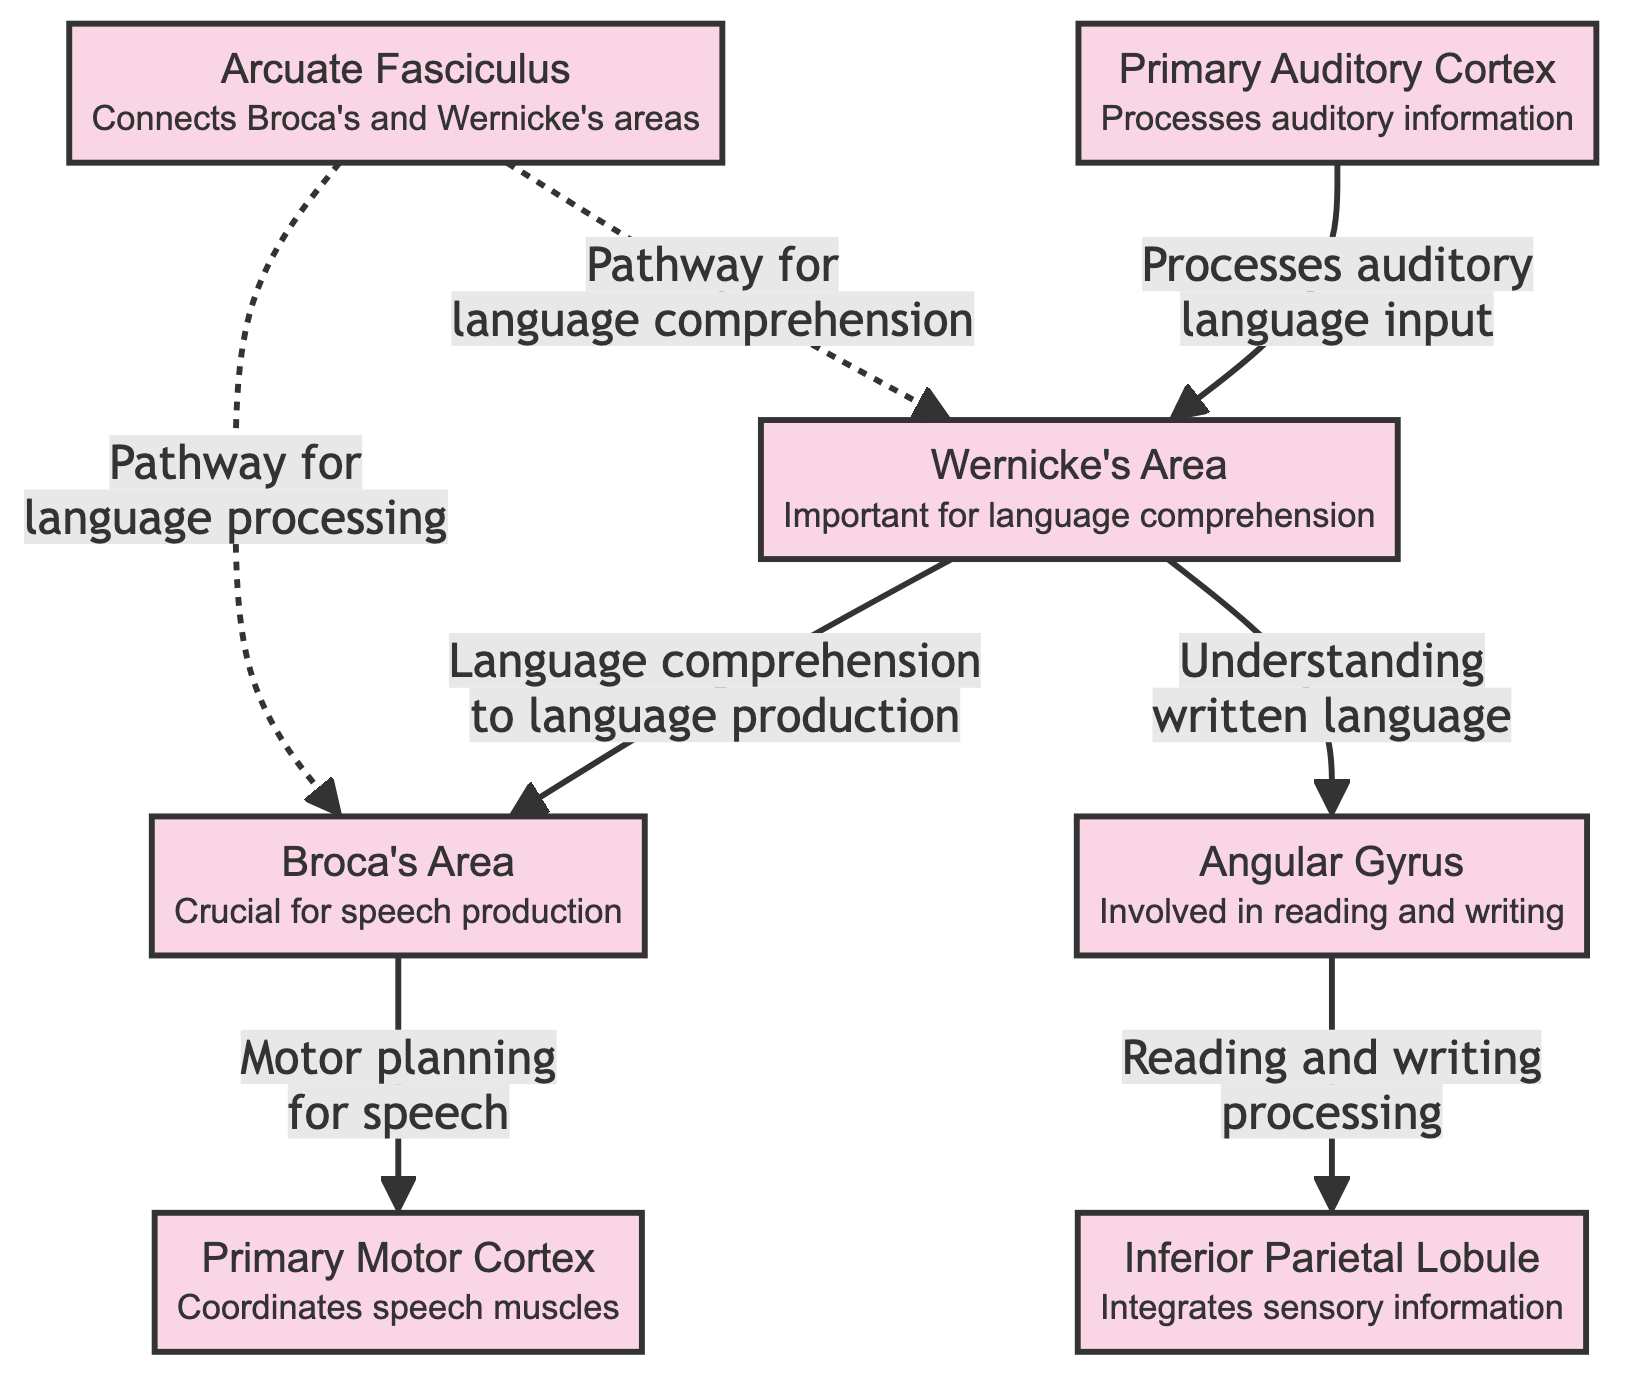What is the main function of Broca's Area? The diagram specifies that Broca's Area is "Crucial for speech production." This directly outlines its primary role in language processing.
Answer: Crucial for speech production Which area is primarily responsible for language comprehension? The diagram indicates that Wernicke's Area is "Important for language comprehension," signifying its key function in understanding language.
Answer: Important for language comprehension How many distinct brain regions are involved in language processing, according to the diagram? The diagram lists a total of 7 distinct brain regions including Broca's Area, Wernicke's Area, Primary Auditory Cortex, Angular Gyrus, Arcuate Fasciculus, Primary Motor Cortex, and Inferior Parietal Lobule.
Answer: 7 Which two regions are connected by the Arcuate Fasciculus? The diagram explicitly shows that the Arcuate Fasciculus connects Broca's Area and Wernicke's Area. This indicates its role as a pathway for language processing.
Answer: Broca's Area and Wernicke's Area How does the Wernicke's Area relate to the Angular Gyrus? The diagram states that Wernicke's Area is involved in "Understanding written language" which is directly linked to the Angular Gyrus for reading and writing processing, showing their functional relationship.
Answer: Understanding written language What is the role of the Primary Motor Cortex in speech? The diagram notes that the Primary Motor Cortex "Coordinates speech muscles," which denotes its essential function in producing spoken language.
Answer: Coordinates speech muscles What is the relationship between the Primary Auditory Cortex and Wernicke's Area? The diagram states that the Primary Auditory Cortex processes auditory language input which then links to Wernicke's Area for further comprehension, illustrating their sequential connection in processing spoken language.
Answer: Processes auditory language input Which brain region integrates sensory information? The diagram identifies the Inferior Parietal Lobule as responsible for integrating sensory information, showcasing its function in language processing.
Answer: Integrates sensory information 